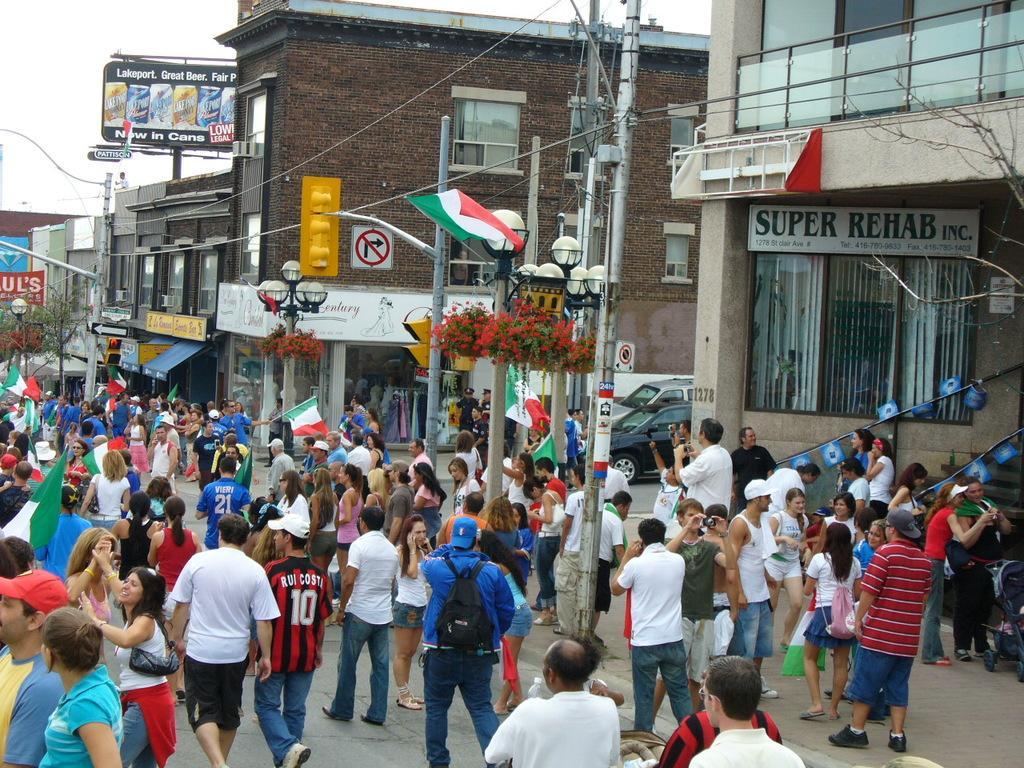Describe this image in one or two sentences. In this picture I see the road on which there are number of people and I see that few of them are holding flags in their hands and I see number of poles and wires and on the right side of this image I see number of buildings and I see 2 cars. In the background I see the sky and I can also see boards on which there is something written. 